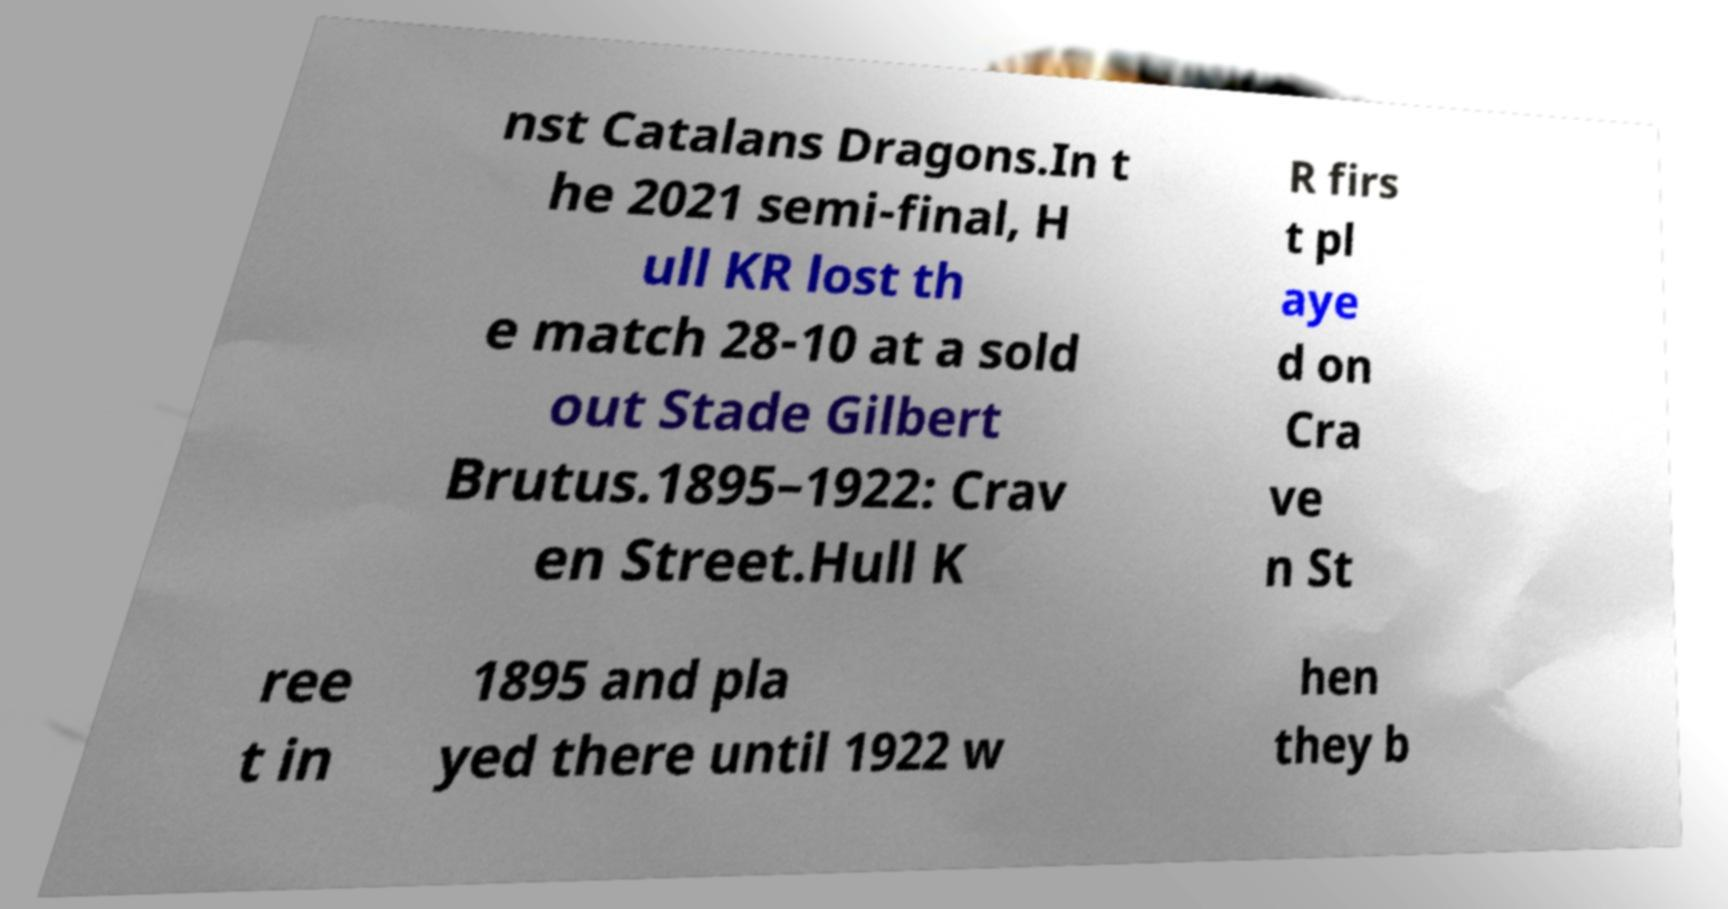Can you accurately transcribe the text from the provided image for me? nst Catalans Dragons.In t he 2021 semi-final, H ull KR lost th e match 28-10 at a sold out Stade Gilbert Brutus.1895–1922: Crav en Street.Hull K R firs t pl aye d on Cra ve n St ree t in 1895 and pla yed there until 1922 w hen they b 